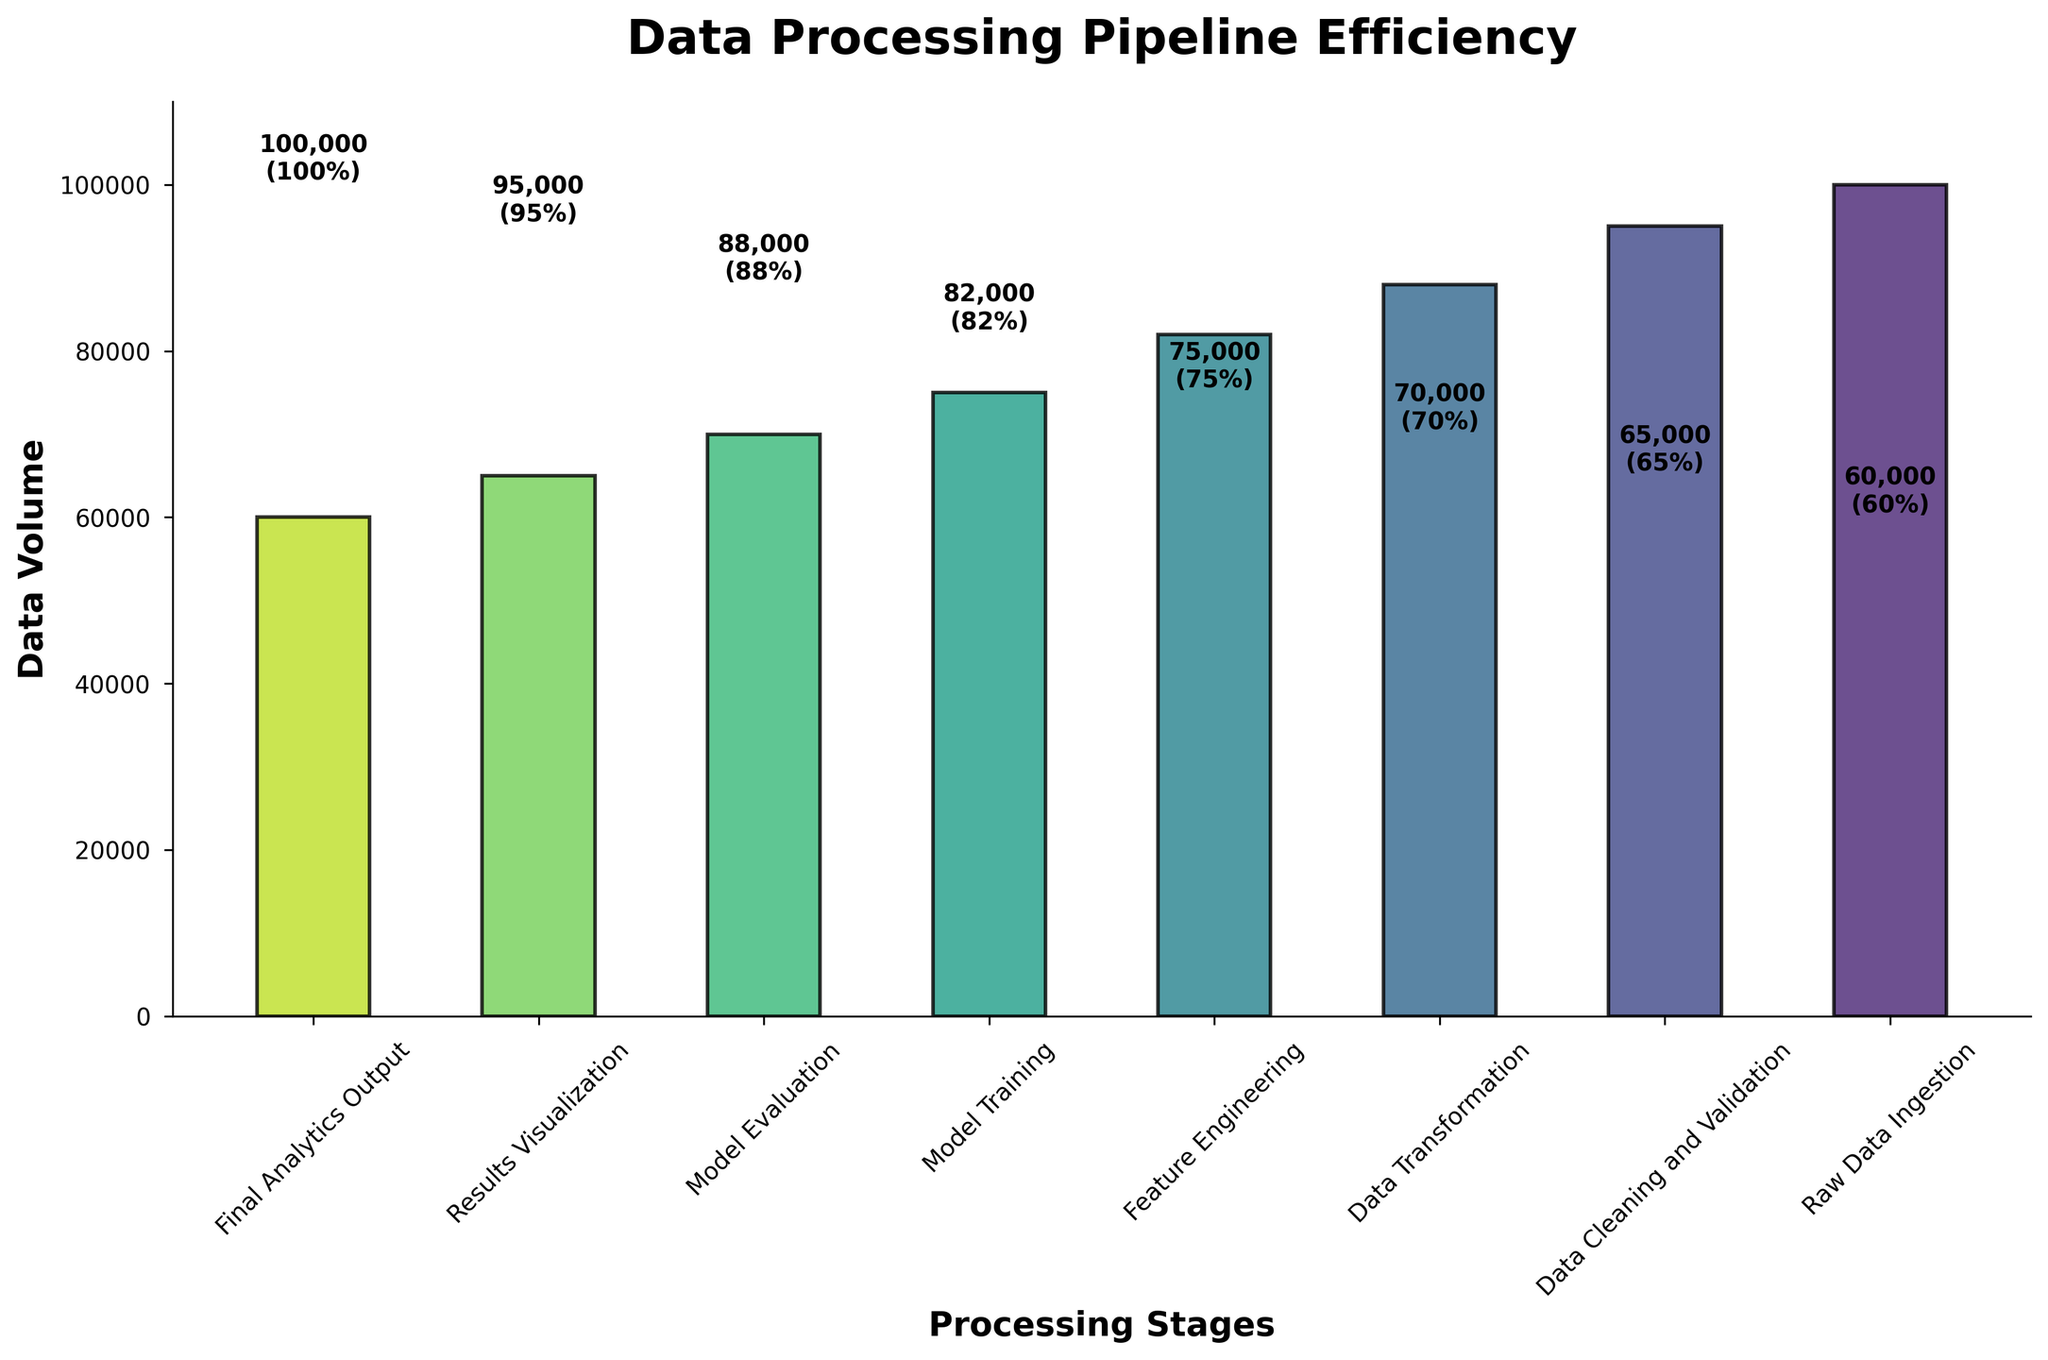What is the title of the chart? The title of the chart is located at the top and is written in bold font.
Answer: Data Processing Pipeline Efficiency How many stages are there in the data processing pipeline? The chart shows multiple bars each representing a stage in the data processing pipeline.
Answer: 7 Describe the overall trend in data volume as we move from Raw Data Ingestion to Final Analytics Output. The volumes decrease from the first stage (Raw Data Ingestion) to the last stage (Final Analytics Output). This can be observed by the reducing height of the bars.
Answer: The data volume decreases What is the volume of data after the Data Cleaning and Validation stage? From the chart, the volume corresponding to the Data Cleaning and Validation stage is displayed on the bar itself.
Answer: 95,000 How much data is lost in the Data Cleaning and Validation stage? To find the data lost, subtract the volume after Data Cleaning and Validation from the initial volume, i.e., 100,000 - 95,000.
Answer: 5,000 Which stage has the highest efficiency? The efficiency values are shown alongside the data volumes on the bars, and by observing, it is clear that 'Raw Data Ingestion' has the highest efficiency.
Answer: Raw Data Ingestion Calculate the percentage decrease in data volume from Feature Engineering to Model Training. Initial data volume in Feature Engineering is 82,000, and in Model Training is 75,000. The percentage decrease is ((82,000 - 75,000) / 82,000) * 100.
Answer: Approximately 8.54% Is the efficiency drop from Data Transformation to Feature Engineering greater than the efficiency drop from Model Training to Model Evaluation? Efficiency drop from Data Transformation to Feature Engineering is (88% - 82%) = 6%. For Model Training to Model Evaluation, it is (75% - 70%) = 5%.
Answer: Yes What is the total data volume after the Feature Engineering stage and Model Evaluation stage combined? After Feature Engineering, the volume is 82,000. After Model Evaluation, the volume is 70,000. Summing these gives 82,000 + 70,000.
Answer: 152,000 Compare the efficiency between the Results Visualization and Final Analytics Output stages. Which one is higher? The efficiency value for Results Visualization is shown as 65% and for Final Analytics Output is 60%.
Answer: Results Visualization 